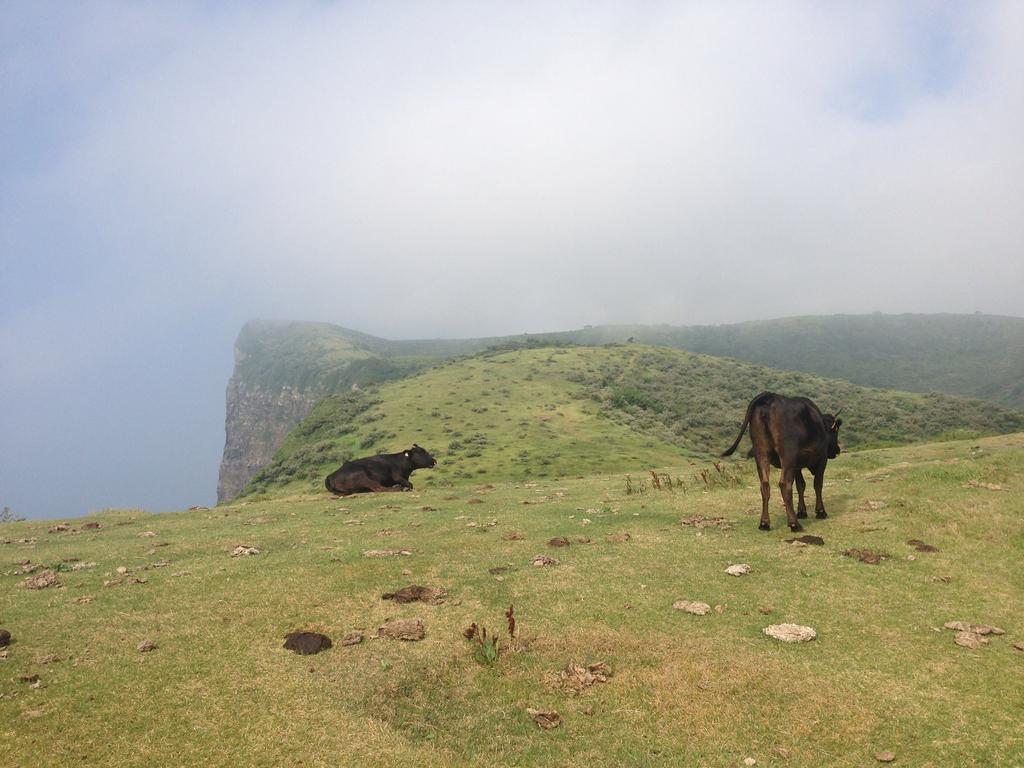Can you describe this image briefly? In the picture we can see a hill covered with grass surface on it, we can see two cows, one is sitting and one is standing and in the background we can see hills and sky with clouds. 